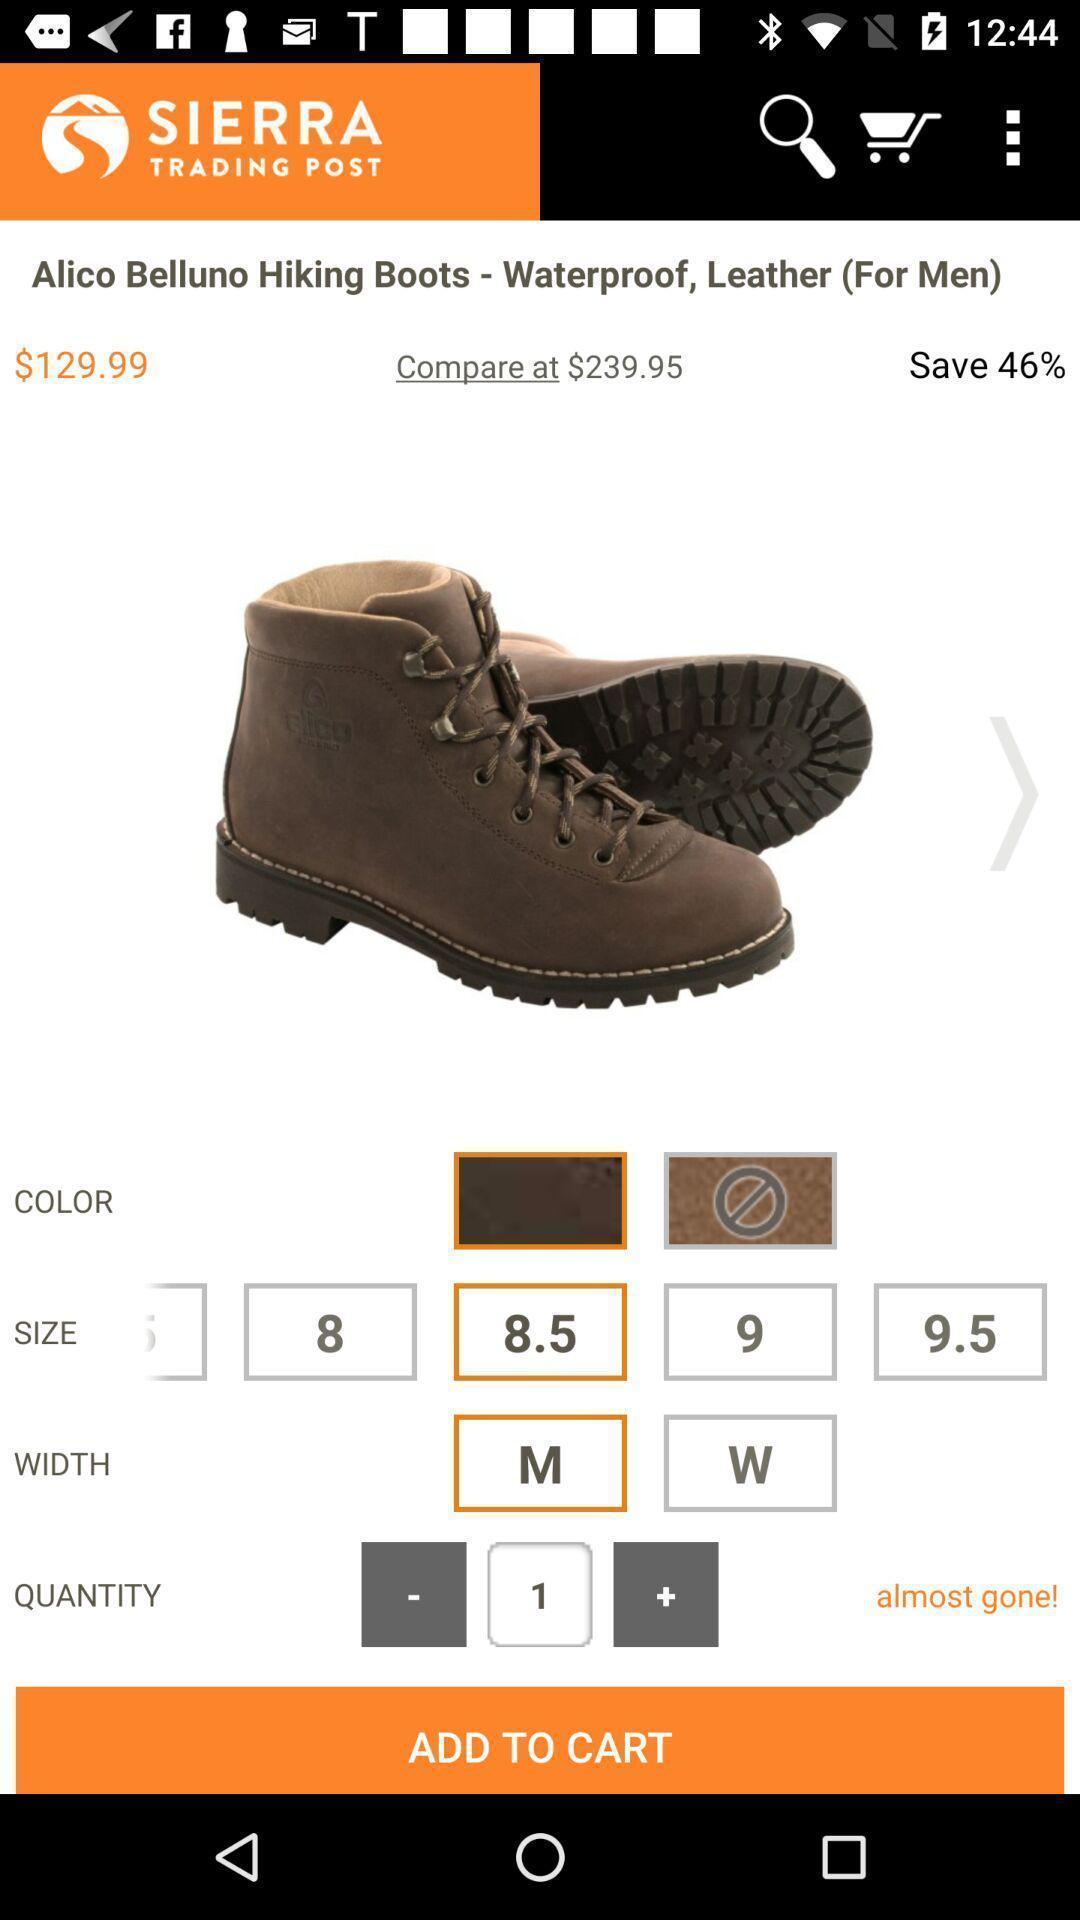Provide a description of this screenshot. Screen displaying the product on a shopping app. 